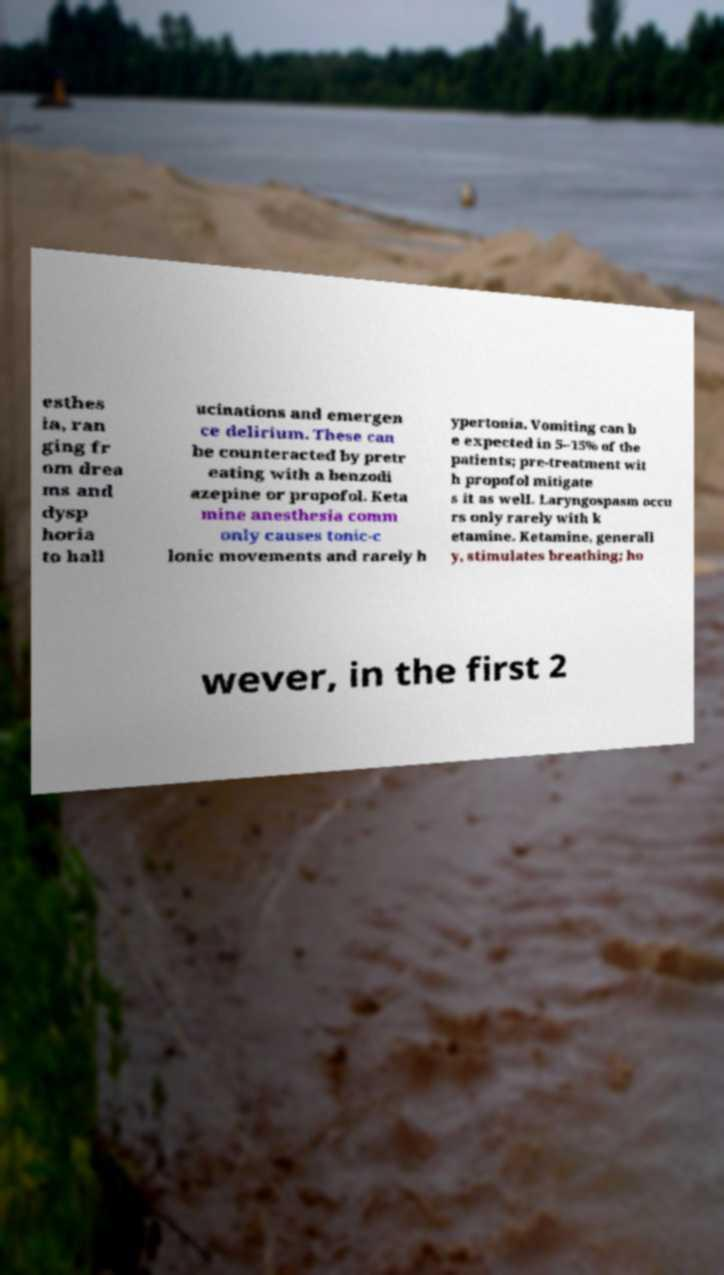What messages or text are displayed in this image? I need them in a readable, typed format. esthes ia, ran ging fr om drea ms and dysp horia to hall ucinations and emergen ce delirium. These can be counteracted by pretr eating with a benzodi azepine or propofol. Keta mine anesthesia comm only causes tonic-c lonic movements and rarely h ypertonia. Vomiting can b e expected in 5–15% of the patients; pre-treatment wit h propofol mitigate s it as well. Laryngospasm occu rs only rarely with k etamine. Ketamine, generall y, stimulates breathing; ho wever, in the first 2 